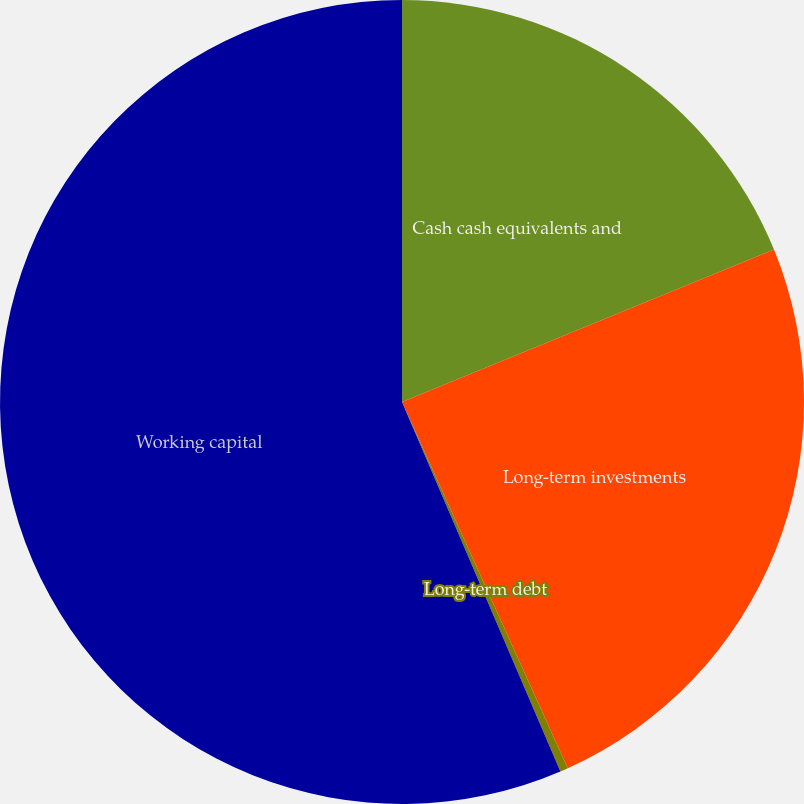Convert chart to OTSL. <chart><loc_0><loc_0><loc_500><loc_500><pie_chart><fcel>Cash cash equivalents and<fcel>Long-term investments<fcel>Long-term debt<fcel>Working capital<nl><fcel>18.81%<fcel>24.42%<fcel>0.32%<fcel>56.44%<nl></chart> 